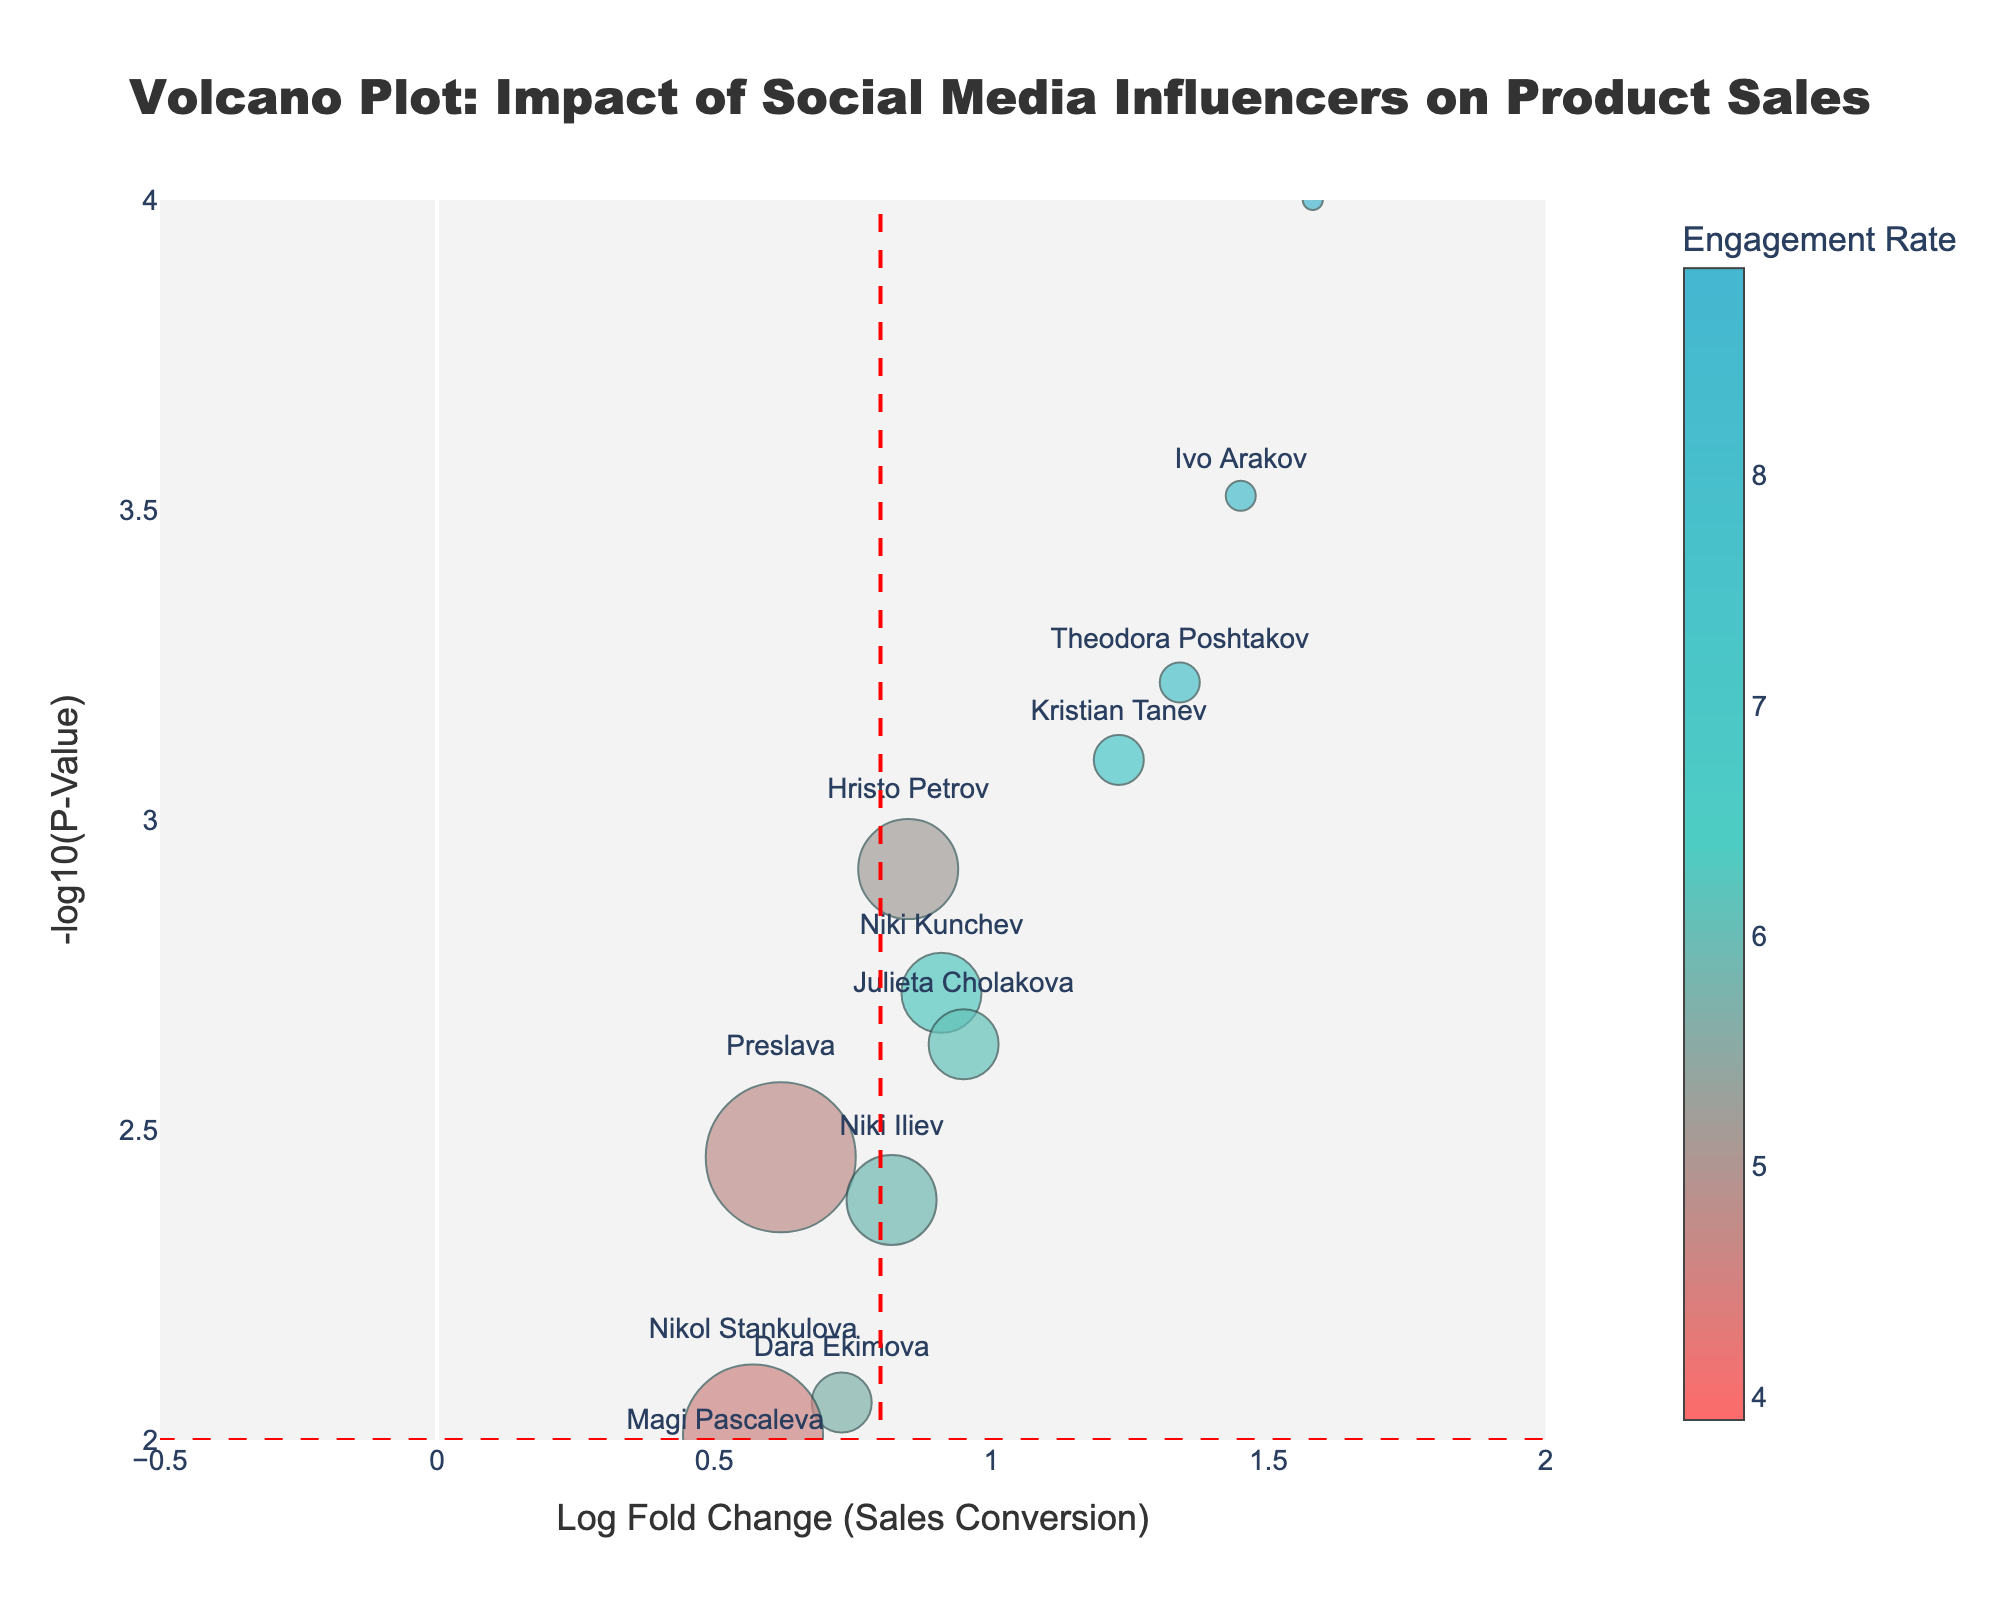What is the title of the plot? The title of the plot is typically found at the top of the figure. In this case, it reads "Volcano Plot: Impact of Social Media Influencers on Product Sales."
Answer: Volcano Plot: Impact of Social Media Influencers on Product Sales How is the engagement rate represented in the figure? The engagement rate is shown using a color scale on the scatter plot. The colors range from light to dark teal, and there is a color bar indicating that higher engagement rates are associated with darker colors.
Answer: By color Which influencer has the highest Log Fold Change (LogFC) value? Look at the x-axis of the scatter plot which represents LogFC values and find the point furthest to the right. The tooltip or text next to this point shows "Svetoslav Ivanov" with the highest LogFC value of 1.58.
Answer: Svetoslav Ivanov How many influencers have a p-value less than 0.01? To determine the number of influencers with a p-value less than 0.01, locate points above the horizontal dashed red line (which represents -log10(p-value) at 0.01) and count them. There are 8 points above this threshold: Hristo Petrov, Kristian Tanev, Niki Kunchev, Ivo Arakov, Theodora Poshtakov, Niki Iliev, Julieta Cholakova, and Svetoslav Ivanov.
Answer: 8 Which influencer has the highest number of followers? Find the data point with the largest marker size, as marker size is determined by the number of followers. Hover over it to see its details or check the annotated text near it. The biggest marker size corresponds to "Maria Bakalova" with 800,000 followers.
Answer: Maria Bakalova What does the vertical red dashed line at LogFC=0.8 signify? Vertical dashed lines often represent thresholds or critical values in volcano plots. The vertical dashed lines at LogFC=0.8 indicate the threshold for Log Fold Change, separating significant changes from less significant ones. Points to the right of 0.8 are considered to have a significant positive impact, while points to the left are less significant.
Answer: Log Fold Change threshold Which influencer has the highest engagement rate? Check the color code and hover over the data points for details. The point with the darkest color (indicating the highest engagement rate) is associated with "Svetoslav Ivanov" with an engagement rate of 8.9%.
Answer: Svetoslav Ivanov Which influencers have both high LogFC and statistically significant p-values? Look for points which are far right (high LogFC) and above the horizontal dashed red line (-log10(p-value) threshold). Influencers fitting this description include Ivo Arakov, Svetoslav Ivanov, and Theodora Poshtakov.
Answer: Ivo Arakov, Svetoslav Ivanov, Theodora Poshtakov 